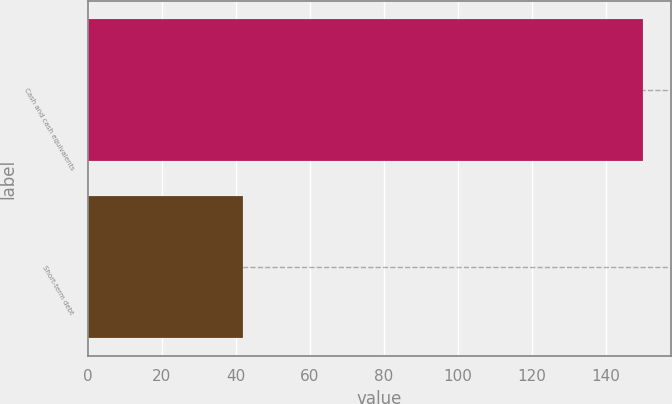<chart> <loc_0><loc_0><loc_500><loc_500><bar_chart><fcel>Cash and cash equivalents<fcel>Short-term debt<nl><fcel>150<fcel>42<nl></chart> 